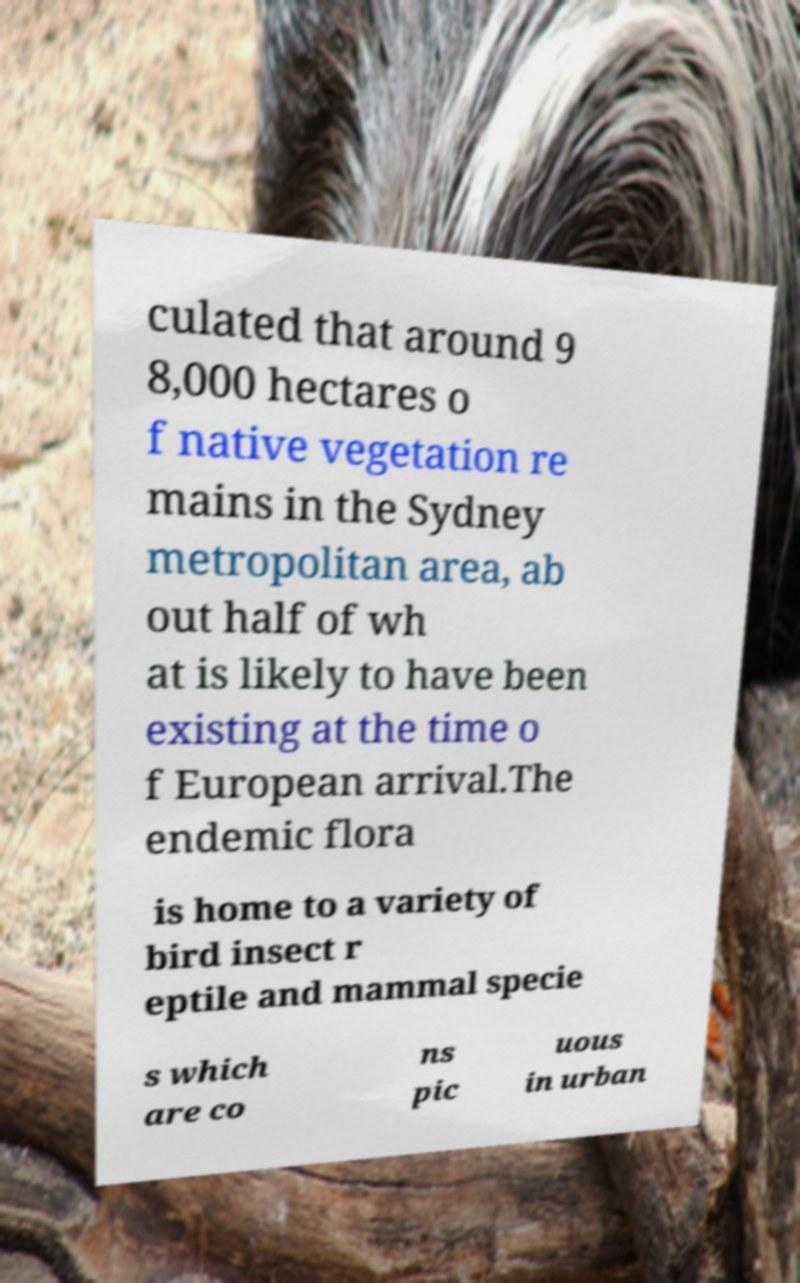Could you assist in decoding the text presented in this image and type it out clearly? culated that around 9 8,000 hectares o f native vegetation re mains in the Sydney metropolitan area, ab out half of wh at is likely to have been existing at the time o f European arrival.The endemic flora is home to a variety of bird insect r eptile and mammal specie s which are co ns pic uous in urban 